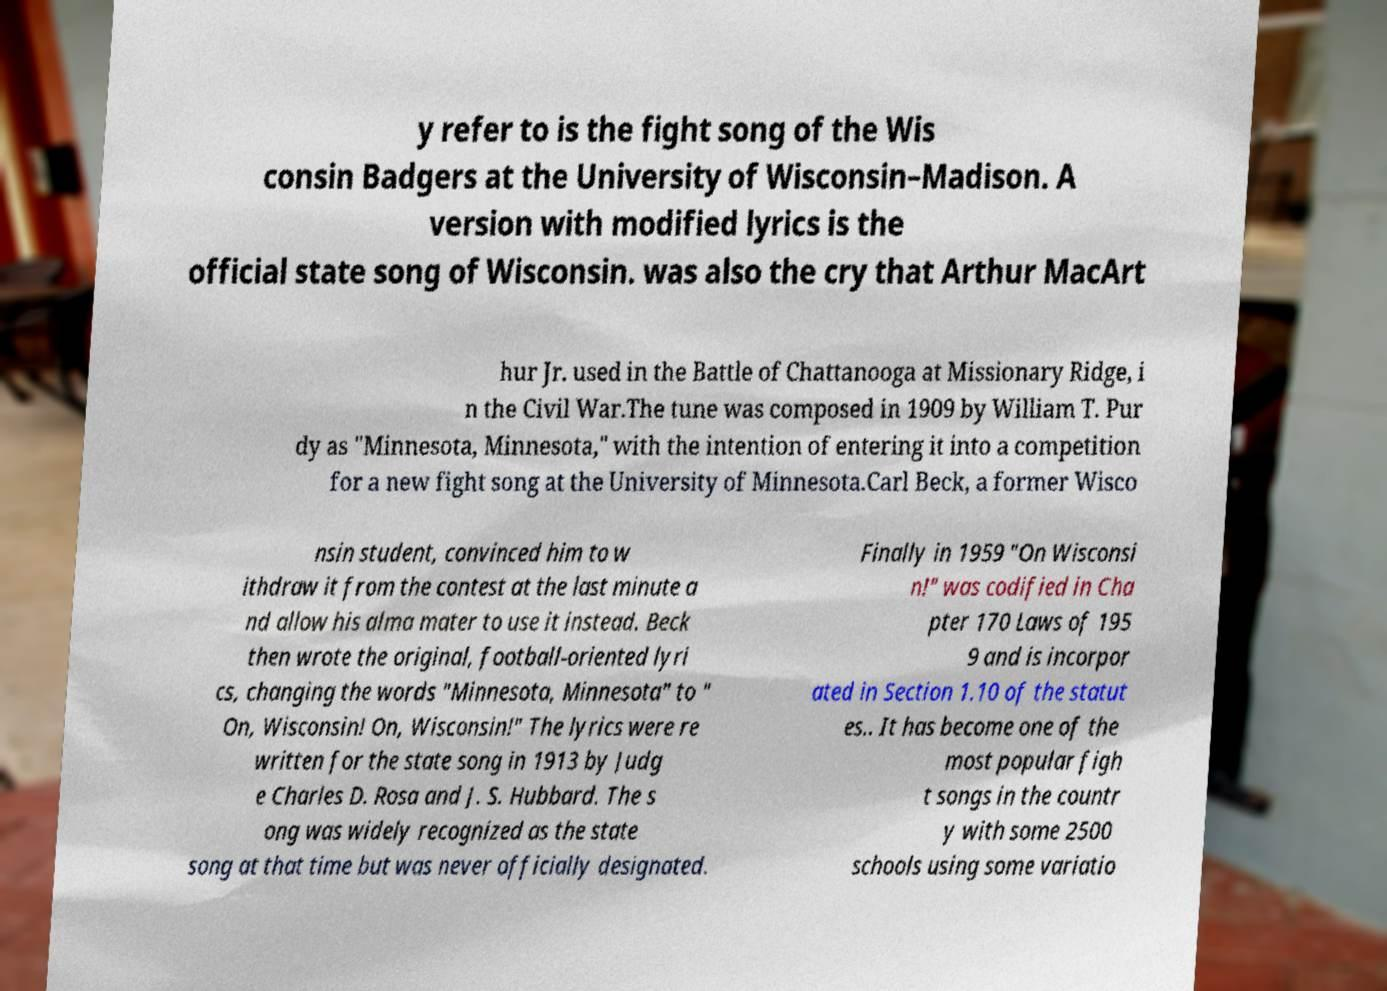I need the written content from this picture converted into text. Can you do that? y refer to is the fight song of the Wis consin Badgers at the University of Wisconsin–Madison. A version with modified lyrics is the official state song of Wisconsin. was also the cry that Arthur MacArt hur Jr. used in the Battle of Chattanooga at Missionary Ridge, i n the Civil War.The tune was composed in 1909 by William T. Pur dy as "Minnesota, Minnesota," with the intention of entering it into a competition for a new fight song at the University of Minnesota.Carl Beck, a former Wisco nsin student, convinced him to w ithdraw it from the contest at the last minute a nd allow his alma mater to use it instead. Beck then wrote the original, football-oriented lyri cs, changing the words "Minnesota, Minnesota" to " On, Wisconsin! On, Wisconsin!" The lyrics were re written for the state song in 1913 by Judg e Charles D. Rosa and J. S. Hubbard. The s ong was widely recognized as the state song at that time but was never officially designated. Finally in 1959 "On Wisconsi n!" was codified in Cha pter 170 Laws of 195 9 and is incorpor ated in Section 1.10 of the statut es.. It has become one of the most popular figh t songs in the countr y with some 2500 schools using some variatio 